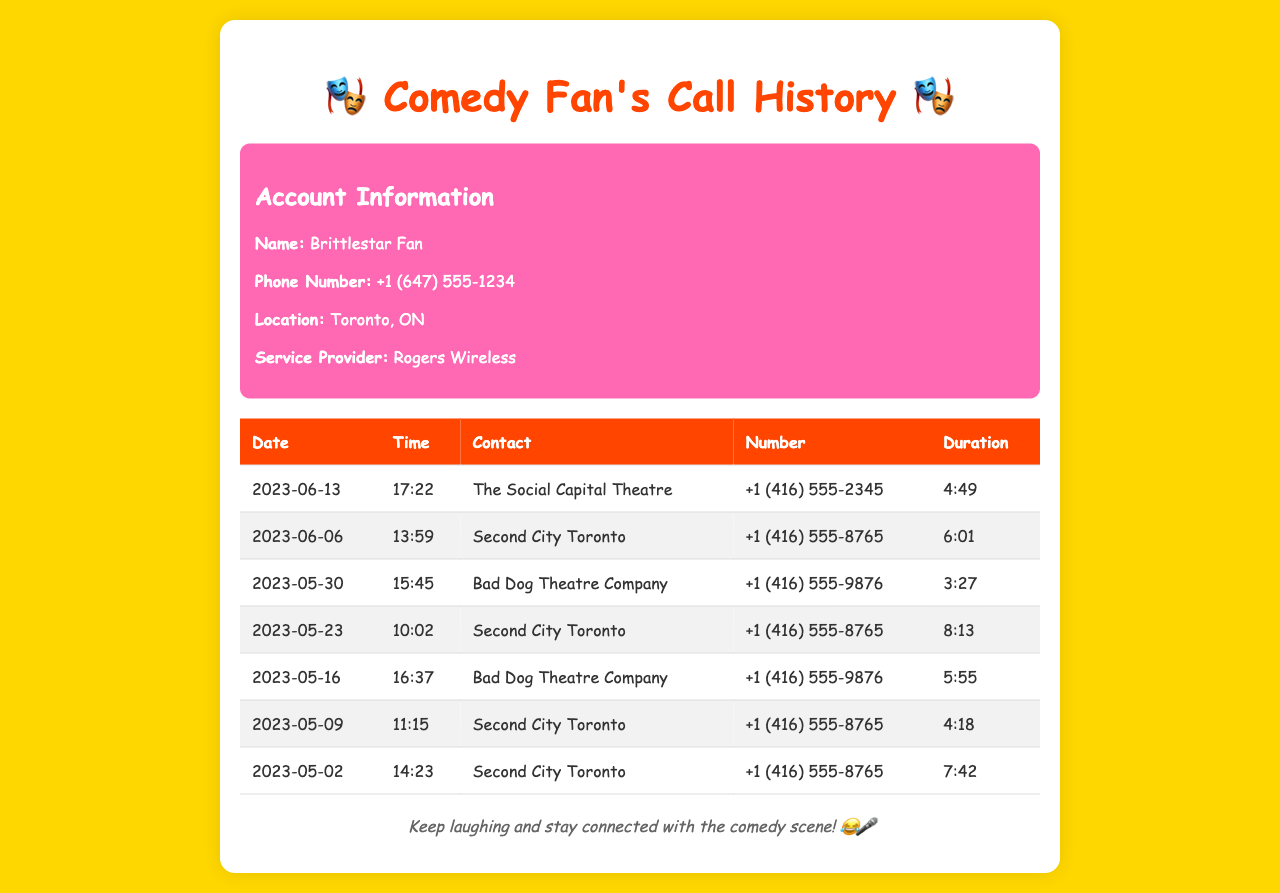What is the name of the first contact? The first contact listed in the call history is The Social Capital Theatre on the date 2023-06-13.
Answer: The Social Capital Theatre What was the duration of the call to Bad Dog Theatre Company on 2023-05-16? The call duration for Bad Dog Theatre Company on 2023-05-16 is recorded as 5 minutes and 55 seconds.
Answer: 5:55 How many times did the contact Second City Toronto appear in the call history? Second City Toronto appears multiple times in the call history, specifically 4 times as evidenced by the dates listed.
Answer: 4 What is the total duration of all calls made to Second City Toronto? To calculate, we sum the durations: 6:01 + 8:13 + 4:18 + 7:42 = 25:14.
Answer: 25:14 What is the phone number for Bad Dog Theatre Company? The phone number listed for Bad Dog Theatre Company in the records is +1 (416) 555-9876.
Answer: +1 (416) 555-9876 Which date had the shortest call duration? The shortest call duration is 3 minutes and 27 seconds for Bad Dog Theatre Company on 2023-05-30.
Answer: 2023-05-30 What time was the call made to Second City Toronto on 2023-05-09? The call to Second City Toronto on 2023-05-09 was made at 11:15 AM.
Answer: 11:15 What color is the background of the document? The background color of the document is a shade of gold, represented as #ffd700.
Answer: gold 